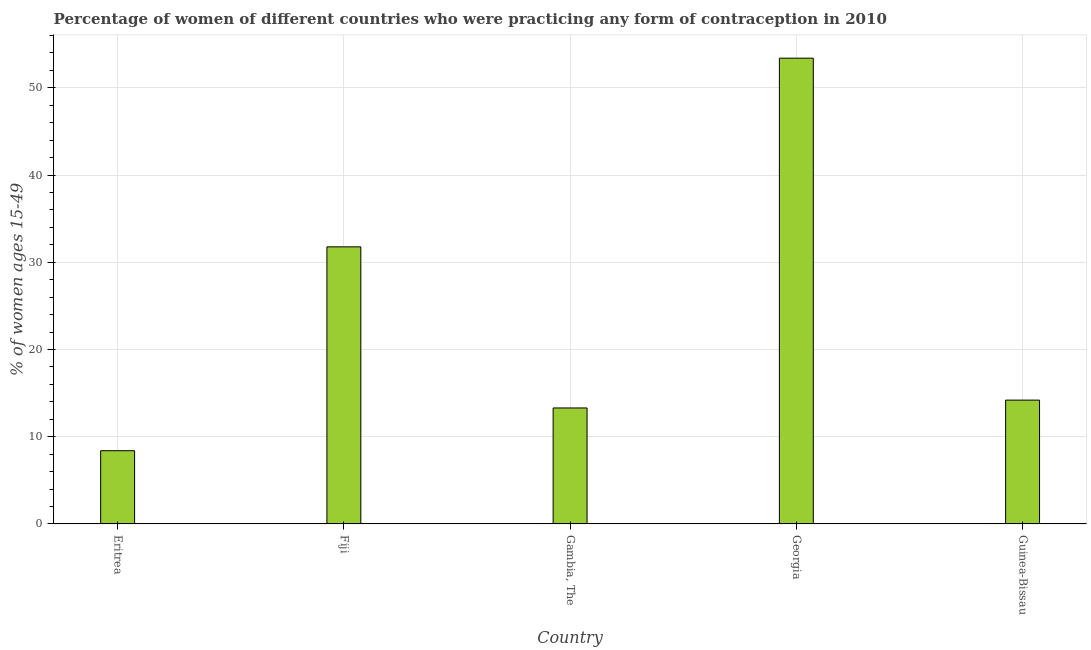Does the graph contain any zero values?
Make the answer very short. No. Does the graph contain grids?
Make the answer very short. Yes. What is the title of the graph?
Keep it short and to the point. Percentage of women of different countries who were practicing any form of contraception in 2010. What is the label or title of the X-axis?
Your answer should be very brief. Country. What is the label or title of the Y-axis?
Offer a terse response. % of women ages 15-49. Across all countries, what is the maximum contraceptive prevalence?
Your answer should be very brief. 53.4. In which country was the contraceptive prevalence maximum?
Give a very brief answer. Georgia. In which country was the contraceptive prevalence minimum?
Ensure brevity in your answer.  Eritrea. What is the sum of the contraceptive prevalence?
Offer a terse response. 121.07. What is the difference between the contraceptive prevalence in Eritrea and Georgia?
Your answer should be compact. -45. What is the average contraceptive prevalence per country?
Ensure brevity in your answer.  24.21. What is the median contraceptive prevalence?
Your answer should be compact. 14.2. In how many countries, is the contraceptive prevalence greater than 28 %?
Your answer should be very brief. 2. What is the ratio of the contraceptive prevalence in Eritrea to that in Gambia, The?
Offer a terse response. 0.63. Is the contraceptive prevalence in Fiji less than that in Guinea-Bissau?
Ensure brevity in your answer.  No. What is the difference between the highest and the second highest contraceptive prevalence?
Provide a succinct answer. 21.63. What is the difference between the highest and the lowest contraceptive prevalence?
Offer a terse response. 45. How many bars are there?
Provide a succinct answer. 5. Are all the bars in the graph horizontal?
Keep it short and to the point. No. What is the % of women ages 15-49 in Fiji?
Offer a terse response. 31.77. What is the % of women ages 15-49 of Georgia?
Your answer should be compact. 53.4. What is the % of women ages 15-49 in Guinea-Bissau?
Offer a very short reply. 14.2. What is the difference between the % of women ages 15-49 in Eritrea and Fiji?
Your answer should be compact. -23.37. What is the difference between the % of women ages 15-49 in Eritrea and Georgia?
Make the answer very short. -45. What is the difference between the % of women ages 15-49 in Eritrea and Guinea-Bissau?
Offer a very short reply. -5.8. What is the difference between the % of women ages 15-49 in Fiji and Gambia, The?
Make the answer very short. 18.47. What is the difference between the % of women ages 15-49 in Fiji and Georgia?
Provide a succinct answer. -21.63. What is the difference between the % of women ages 15-49 in Fiji and Guinea-Bissau?
Offer a very short reply. 17.57. What is the difference between the % of women ages 15-49 in Gambia, The and Georgia?
Offer a very short reply. -40.1. What is the difference between the % of women ages 15-49 in Gambia, The and Guinea-Bissau?
Give a very brief answer. -0.9. What is the difference between the % of women ages 15-49 in Georgia and Guinea-Bissau?
Keep it short and to the point. 39.2. What is the ratio of the % of women ages 15-49 in Eritrea to that in Fiji?
Offer a very short reply. 0.26. What is the ratio of the % of women ages 15-49 in Eritrea to that in Gambia, The?
Offer a very short reply. 0.63. What is the ratio of the % of women ages 15-49 in Eritrea to that in Georgia?
Offer a very short reply. 0.16. What is the ratio of the % of women ages 15-49 in Eritrea to that in Guinea-Bissau?
Ensure brevity in your answer.  0.59. What is the ratio of the % of women ages 15-49 in Fiji to that in Gambia, The?
Provide a short and direct response. 2.39. What is the ratio of the % of women ages 15-49 in Fiji to that in Georgia?
Provide a succinct answer. 0.59. What is the ratio of the % of women ages 15-49 in Fiji to that in Guinea-Bissau?
Provide a short and direct response. 2.24. What is the ratio of the % of women ages 15-49 in Gambia, The to that in Georgia?
Your response must be concise. 0.25. What is the ratio of the % of women ages 15-49 in Gambia, The to that in Guinea-Bissau?
Your answer should be compact. 0.94. What is the ratio of the % of women ages 15-49 in Georgia to that in Guinea-Bissau?
Ensure brevity in your answer.  3.76. 